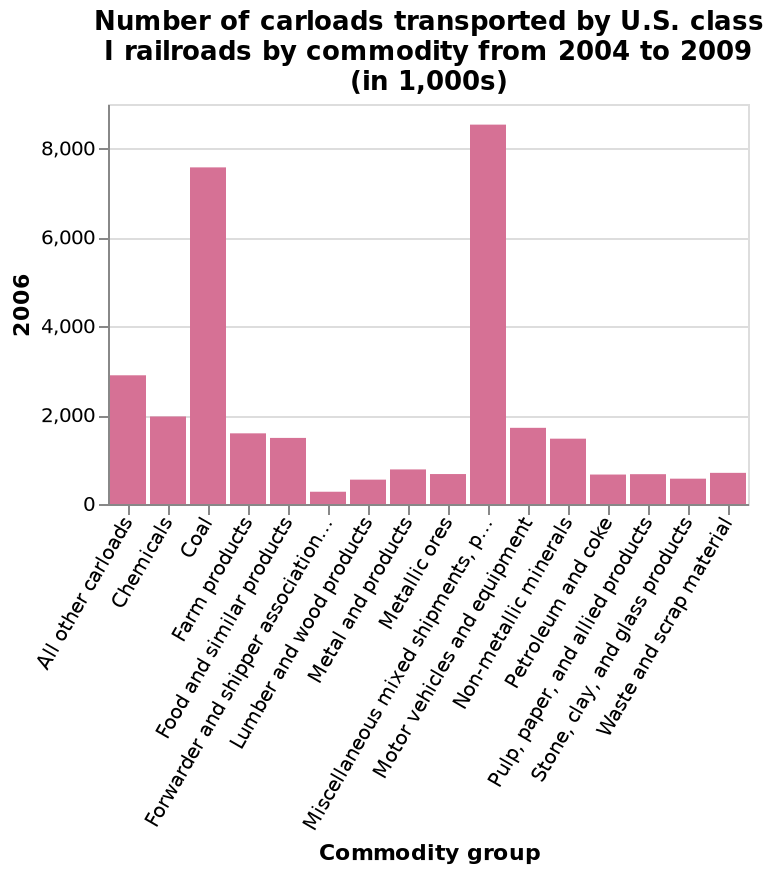<image>
What is the unit of measurement used in the graph? The unit of measurement used in the graph is "1,000s". Describe the following image in detail Number of carloads transported by U.S. class I railroads by commodity from 2004 to 2009 (in 1,000s) is a bar graph. The y-axis shows 2006 while the x-axis plots Commodity group. What is the state of coal and miscellaneous energy sources? The state of coal and miscellaneous energy sources remains steady. What is the level of coal and miscellaneous energy sources?  The level of coal and miscellaneous energy sources remains high. Are all other energy sources stable?  Yes, all other energy sources are steady. 